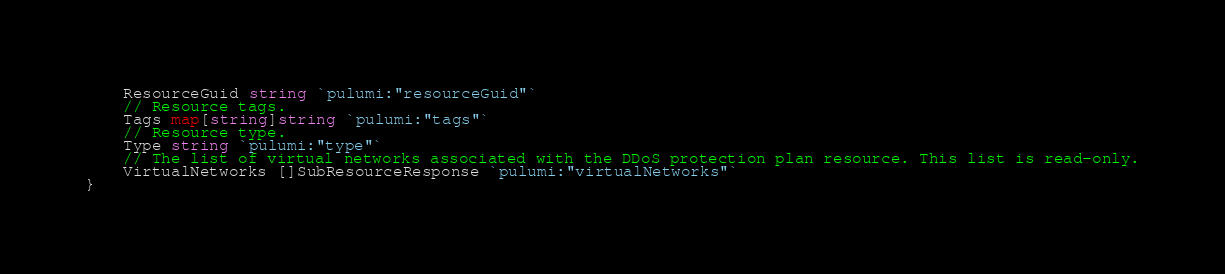<code> <loc_0><loc_0><loc_500><loc_500><_Go_>	ResourceGuid string `pulumi:"resourceGuid"`
	// Resource tags.
	Tags map[string]string `pulumi:"tags"`
	// Resource type.
	Type string `pulumi:"type"`
	// The list of virtual networks associated with the DDoS protection plan resource. This list is read-only.
	VirtualNetworks []SubResourceResponse `pulumi:"virtualNetworks"`
}
</code> 